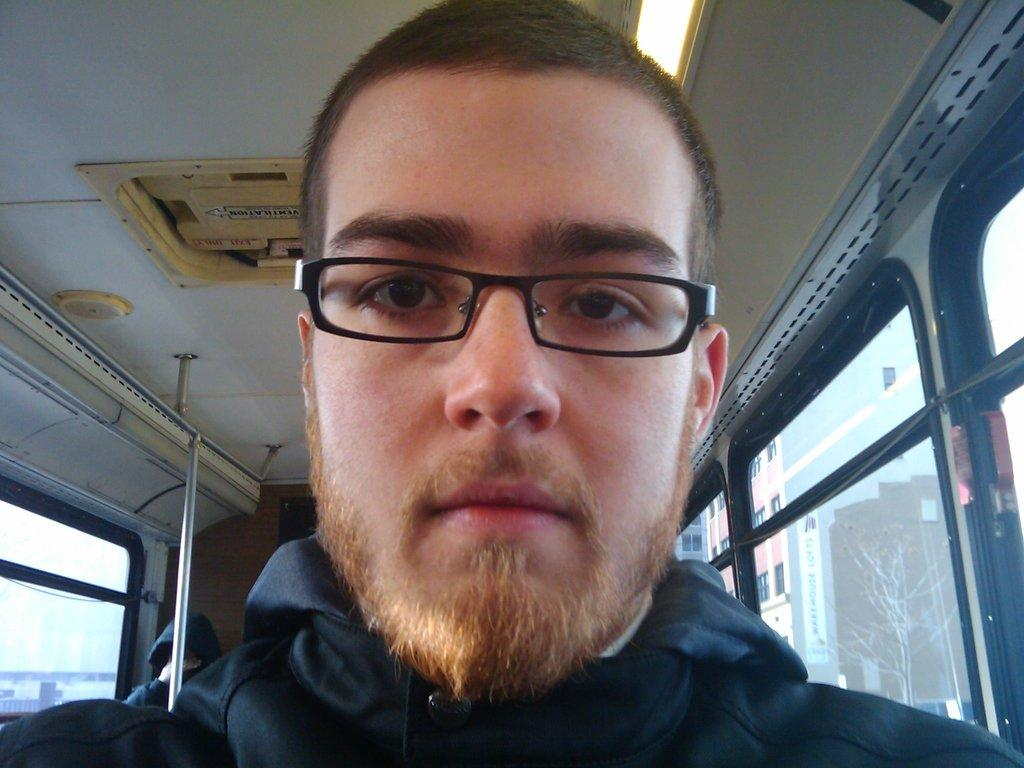Where was the image taken? The image was taken inside a vehicle. Can you describe the person in the image? There is a man wearing spectacles in the image. What type of windows are present in the vehicle? There are glass windows in the vehicle. What is the purpose of the pole in the vehicle? The pole in the vehicle is likely used for support or stability. What can be seen through the windows of the vehicle? Buildings, trees, and the sky are visible through the windows. What type of banana is being used as a decoration in the vehicle? There is no banana present in the image, let alone being used as a decoration. What industry is being represented by the person in the vehicle? The image does not provide any information about the person's industry or occupation. 